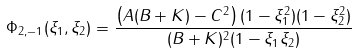<formula> <loc_0><loc_0><loc_500><loc_500>\Phi _ { 2 , - 1 } ( \xi _ { 1 } , \xi _ { 2 } ) = \frac { \left ( A ( B + K ) - C ^ { 2 } \right ) ( 1 - \xi _ { 1 } ^ { 2 } ) ( 1 - \xi _ { 2 } ^ { 2 } ) } { ( B + K ) ^ { 2 } ( 1 - \xi _ { 1 } \xi _ { 2 } ) }</formula> 